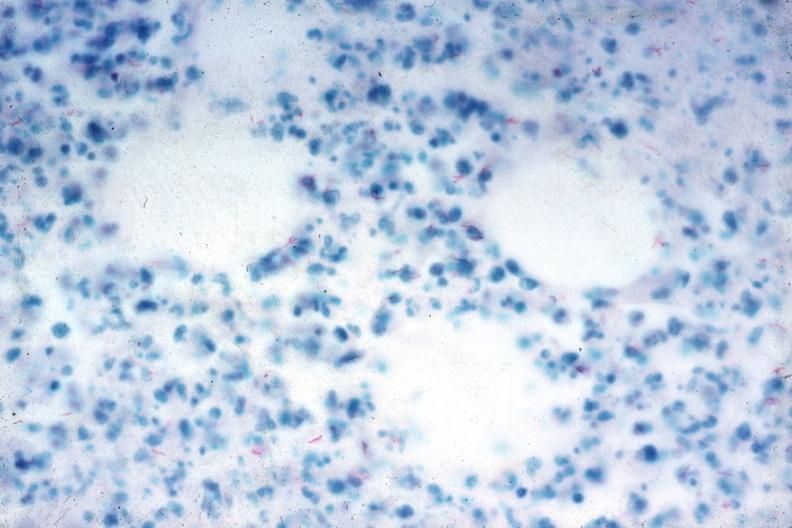what is present?
Answer the question using a single word or phrase. Abdomen 